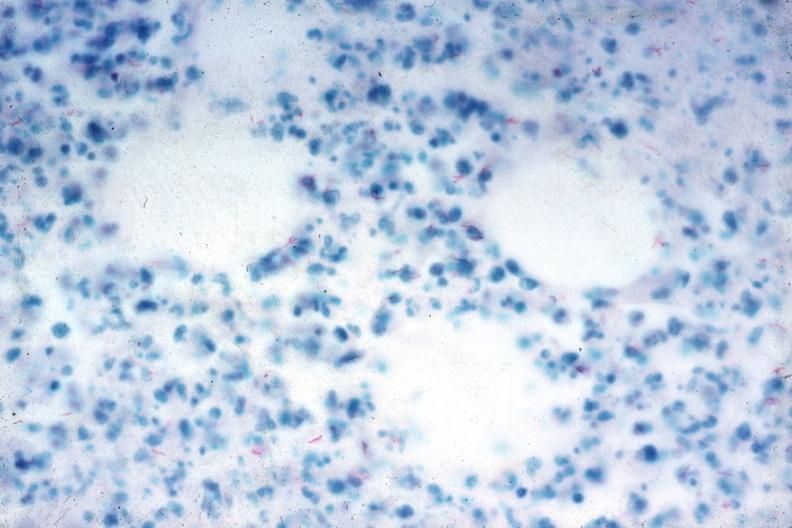what is present?
Answer the question using a single word or phrase. Abdomen 